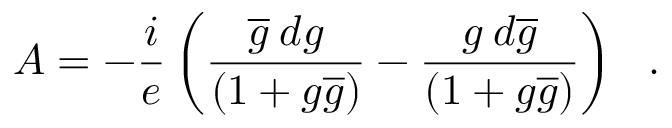<formula> <loc_0><loc_0><loc_500><loc_500>A = - \frac { i } { e } \left ( \frac { \overline { g } \, d g } { ( 1 + g \overline { g } ) } - \frac { g \, d \overline { g } } { ( 1 + g \overline { g } ) } \right ) .</formula> 